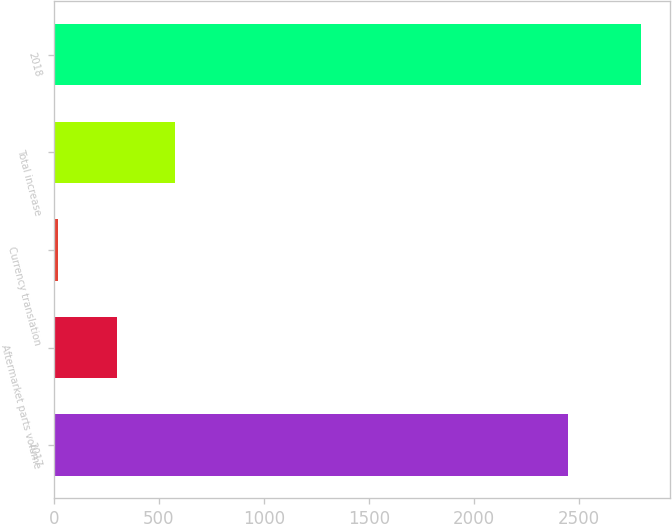Convert chart to OTSL. <chart><loc_0><loc_0><loc_500><loc_500><bar_chart><fcel>2017<fcel>Aftermarket parts volume<fcel>Currency translation<fcel>Total increase<fcel>2018<nl><fcel>2445.8<fcel>298.61<fcel>21.4<fcel>575.82<fcel>2793.5<nl></chart> 